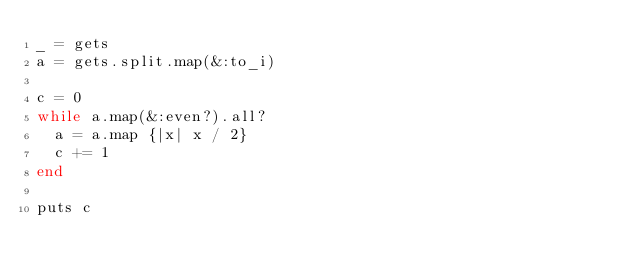<code> <loc_0><loc_0><loc_500><loc_500><_Ruby_>_ = gets
a = gets.split.map(&:to_i)

c = 0
while a.map(&:even?).all?
  a = a.map {|x| x / 2}
  c += 1
end

puts c</code> 